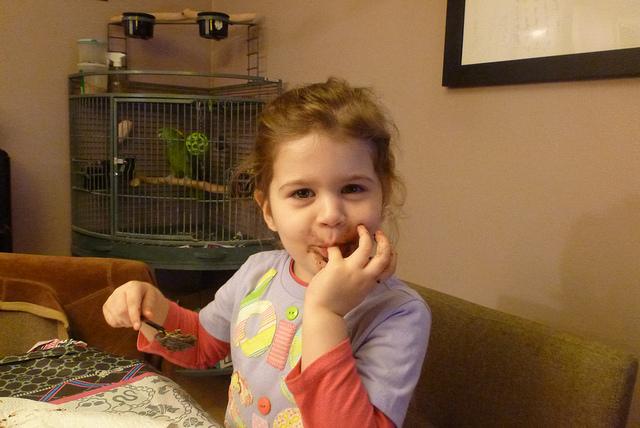Where is the little girl?
Concise answer only. Table. Does the girl have great table manners?
Concise answer only. No. What's in the girls mouth?
Write a very short answer. Finger. Is the child reading a book?
Short answer required. No. Where is the child sitting?
Quick response, please. Chair. Any of the objects in the girls hand alive?
Quick response, please. No. What type of bird is in the background?
Concise answer only. Parrot. Is the child looking at the camera?
Answer briefly. Yes. Is there a quilt?
Short answer required. No. What is this child eating?
Give a very brief answer. Chocolate. What does her shirt say?
Concise answer only. Big sis. Does this person own a cat?
Concise answer only. No. How many people are awake?
Short answer required. 1. Is this a baby?
Answer briefly. No. What is the child eating?
Give a very brief answer. Chocolate. Is she wearing a ring?
Give a very brief answer. No. 